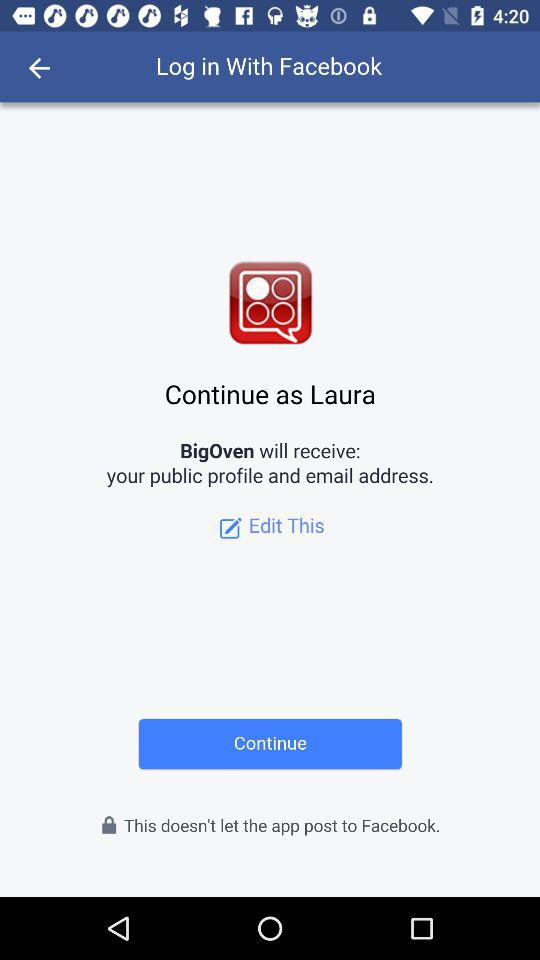What application is asking for permission? The application "BigOven" is asking for permission. 